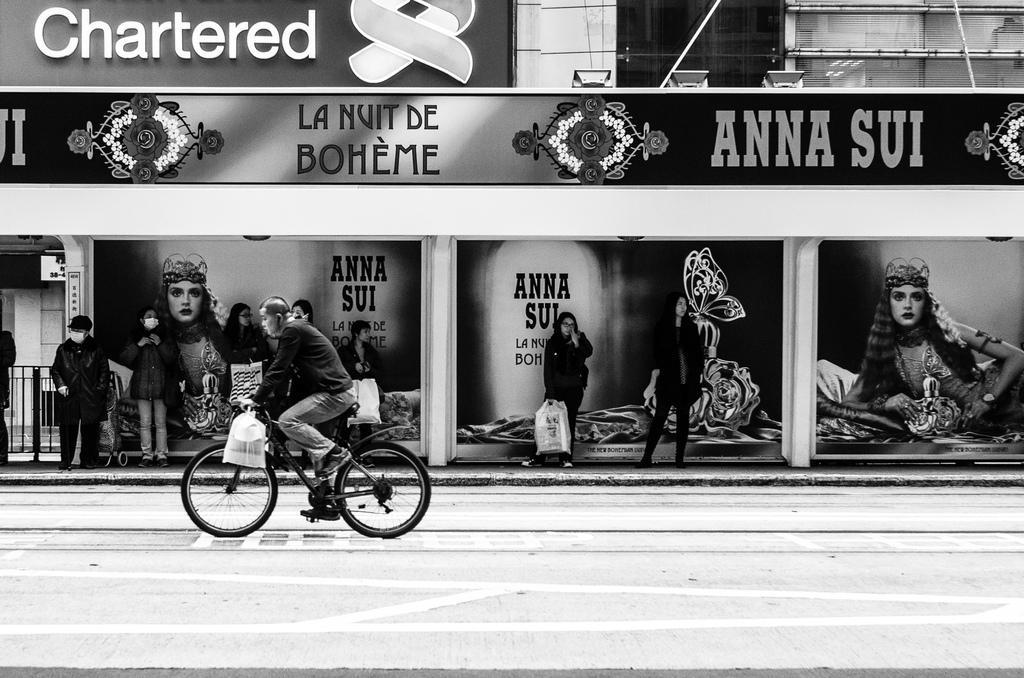Please provide a concise description of this image. This is the picture of a place where we have a person riding the bicycle and behind there are some people standing under the shed which has some boards and some lights. 